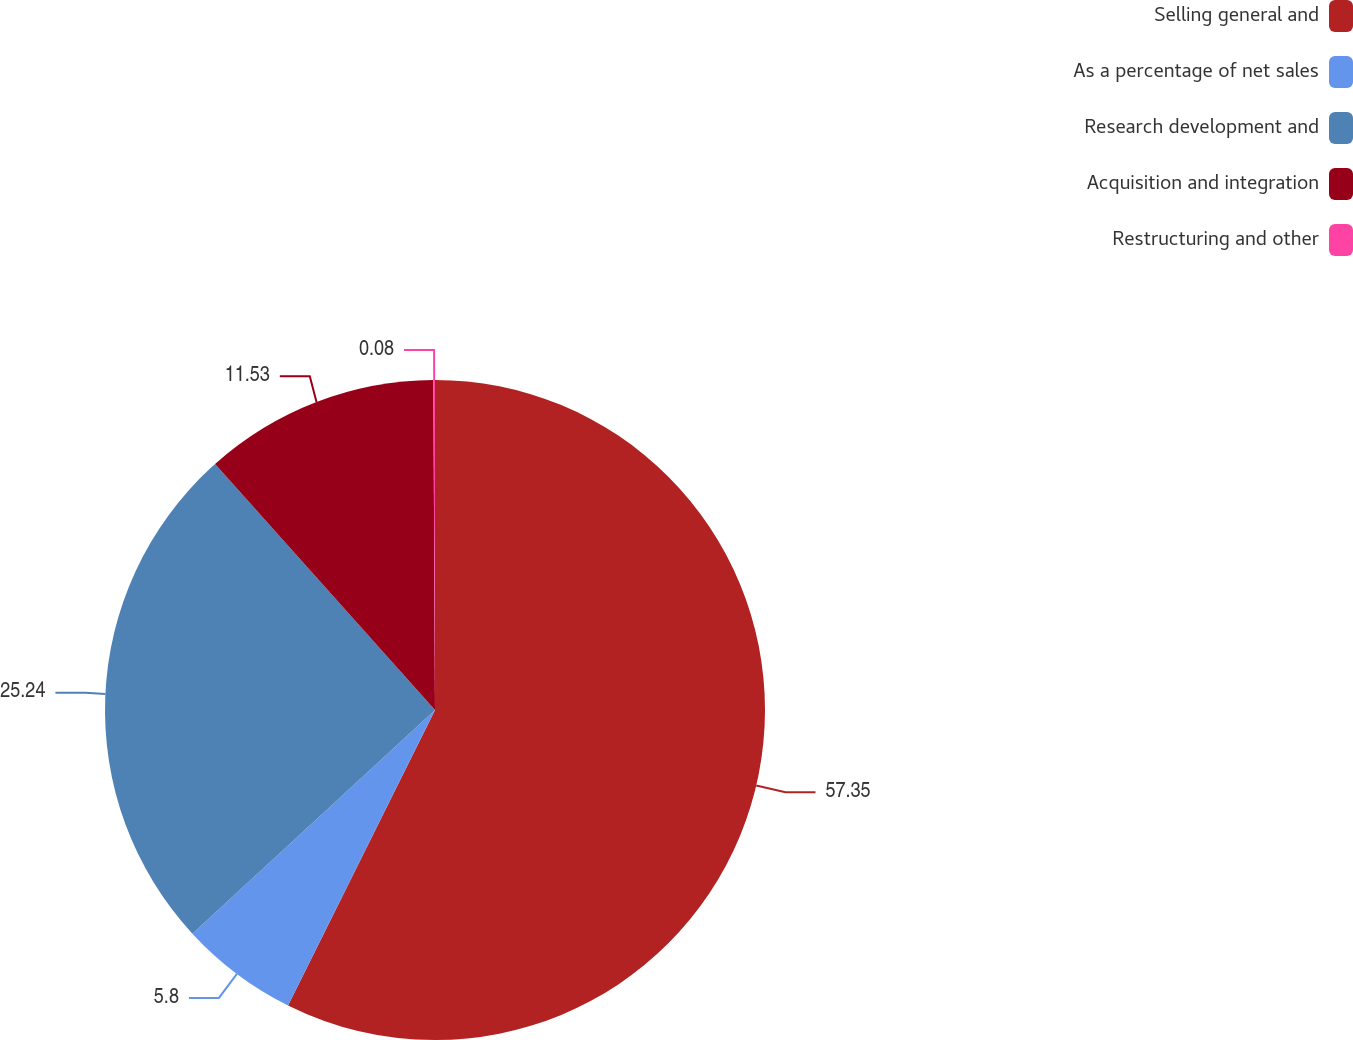<chart> <loc_0><loc_0><loc_500><loc_500><pie_chart><fcel>Selling general and<fcel>As a percentage of net sales<fcel>Research development and<fcel>Acquisition and integration<fcel>Restructuring and other<nl><fcel>57.34%<fcel>5.8%<fcel>25.24%<fcel>11.53%<fcel>0.08%<nl></chart> 